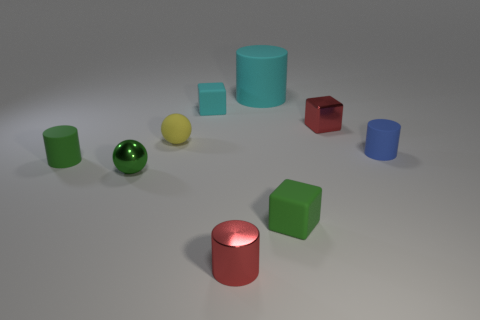What can you infer about the source of light in this arrangement? Analyzing the shadows and highlights on the objects, the light source appears to be positioned above and slightly to the right of the scene. The defined shadows cast by the objects suggest a single, possibly concentrated light source, giving the setup a controlled, almost studio-like ambiance. Could you tell me more about the texture and material differences among these objects? Absolutely. Upon closer inspection, we notice that the cylinders and cubes exhibit a solid, slightly matte surface, except for the larger cylinder which has a distinctly matte finish. In contrast, the spheres have a glossy, reflective surface that mirrors their surroundings. These textural contrasts add depth to the composition and could be an exploration of how different materials interact with light. 